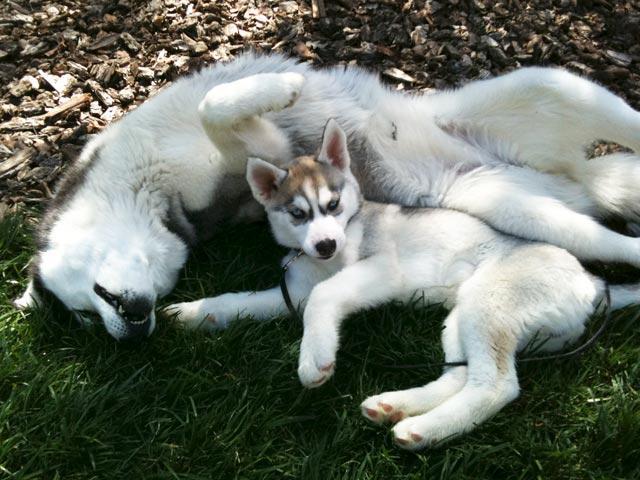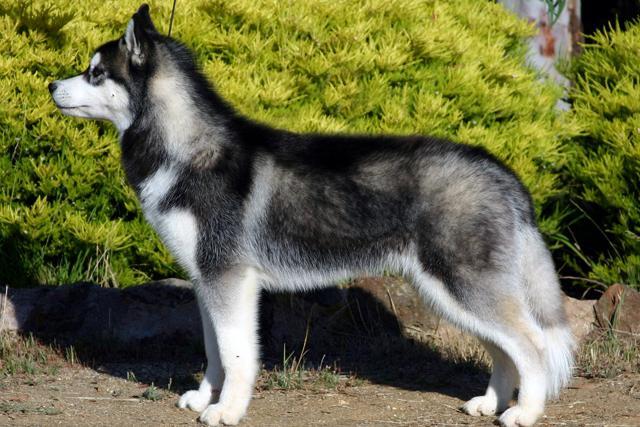The first image is the image on the left, the second image is the image on the right. Assess this claim about the two images: "There are three dogs.". Correct or not? Answer yes or no. Yes. 